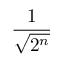<formula> <loc_0><loc_0><loc_500><loc_500>\frac { 1 } { \sqrt { 2 ^ { n } } }</formula> 